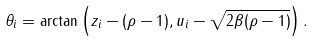Convert formula to latex. <formula><loc_0><loc_0><loc_500><loc_500>\theta _ { i } = \arctan \left ( z _ { i } - ( \rho - 1 ) , u _ { i } - \sqrt { 2 \beta ( \rho - 1 ) } \right ) .</formula> 